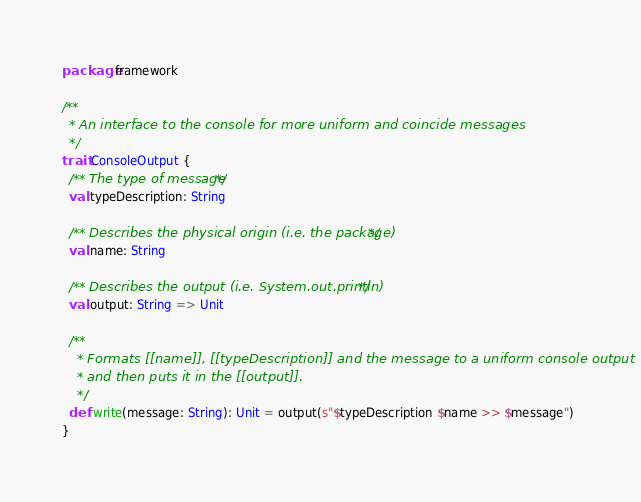<code> <loc_0><loc_0><loc_500><loc_500><_Scala_>package framework

/**
  * An interface to the console for more uniform and coincide messages
  */
trait ConsoleOutput {
  /** The type of message */
  val typeDescription: String

  /** Describes the physical origin (i.e. the package) */
  val name: String

  /** Describes the output (i.e. System.out.println) */
  val output: String => Unit

  /**
    * Formats [[name]], [[typeDescription]] and the message to a uniform console output
    * and then puts it in the [[output]].
    */
  def write(message: String): Unit = output(s"$typeDescription $name >> $message")
}
</code> 